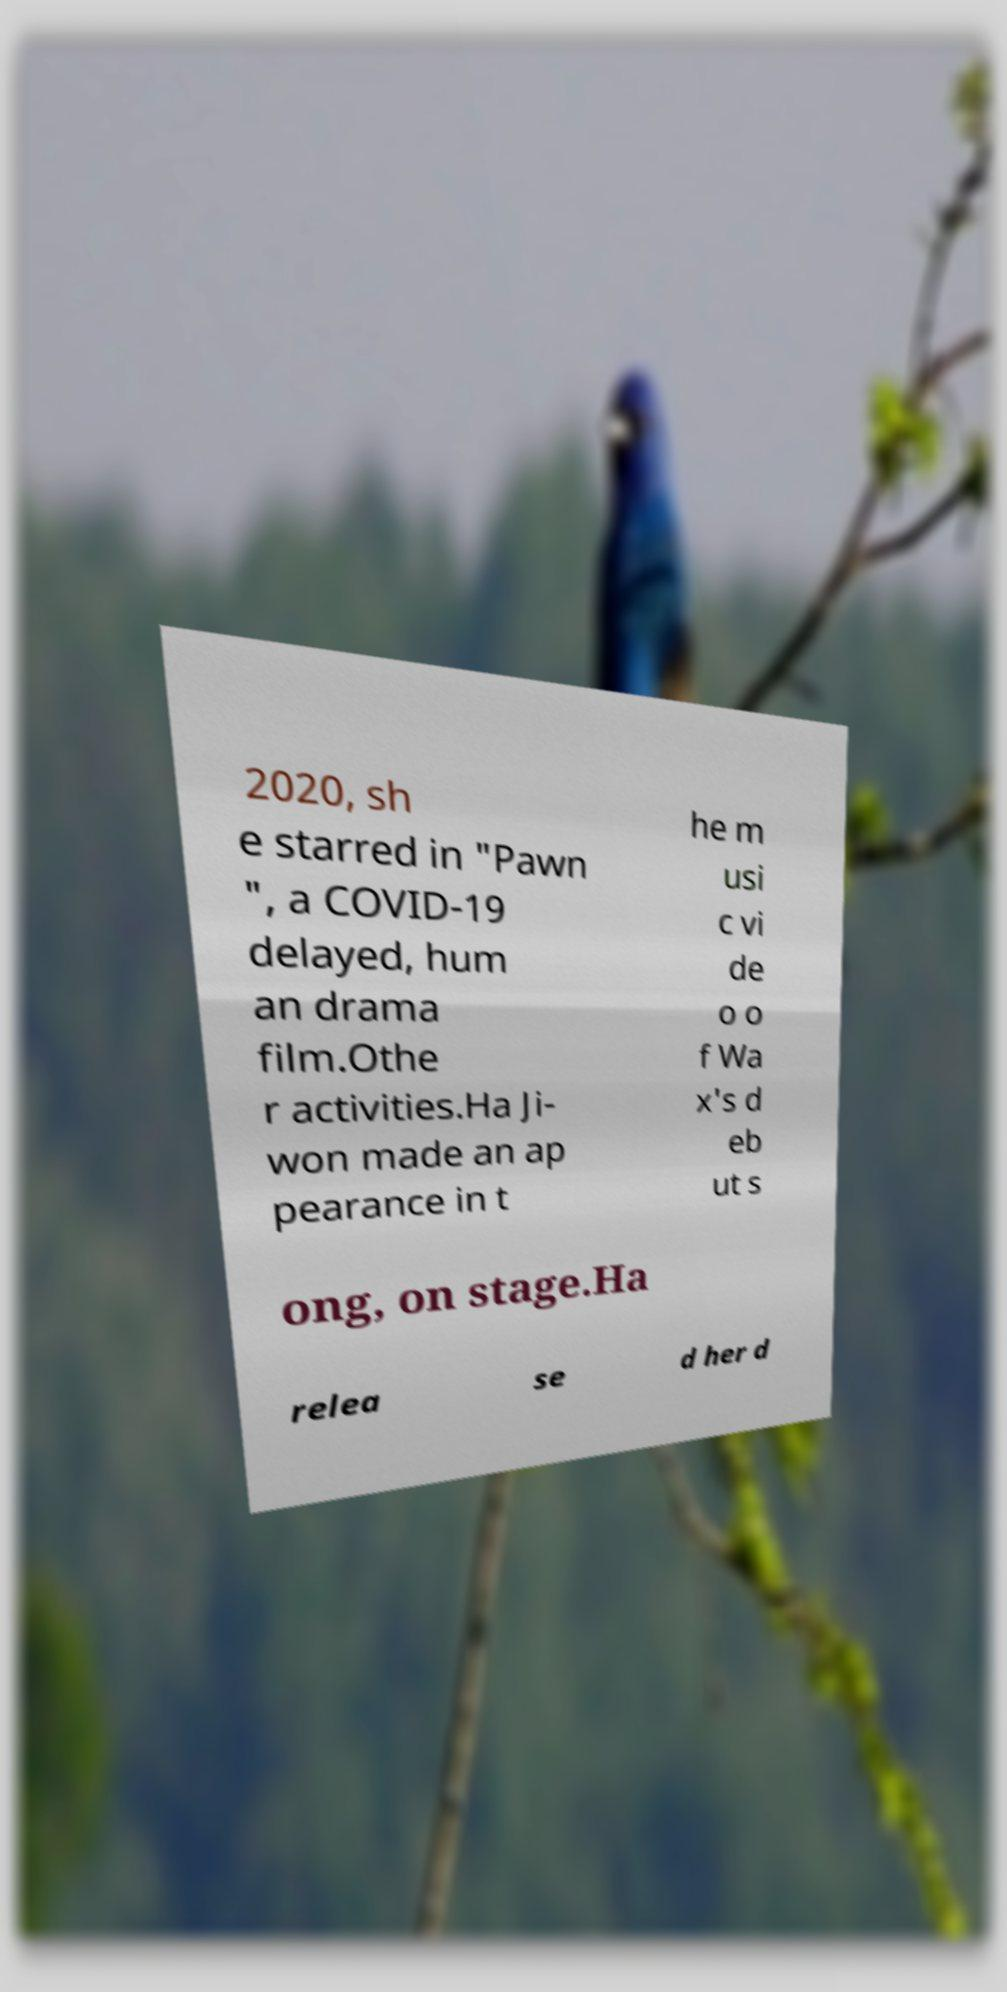What messages or text are displayed in this image? I need them in a readable, typed format. 2020, sh e starred in "Pawn ", a COVID-19 delayed, hum an drama film.Othe r activities.Ha Ji- won made an ap pearance in t he m usi c vi de o o f Wa x's d eb ut s ong, on stage.Ha relea se d her d 